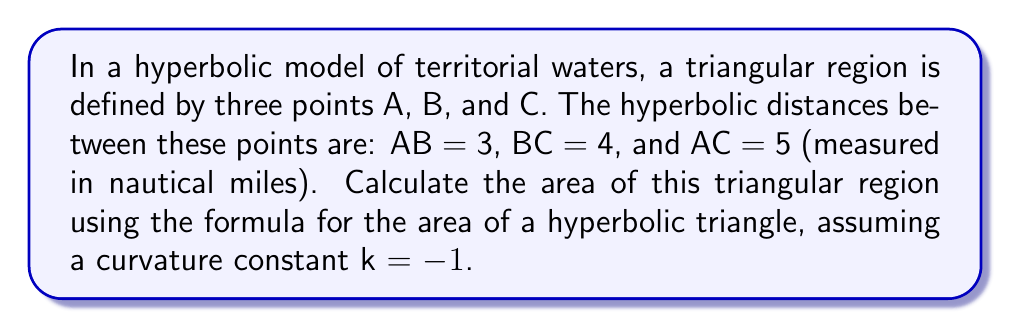Help me with this question. To solve this problem, we'll use the hyperbolic law of cosines and the area formula for a hyperbolic triangle. Let's proceed step-by-step:

1. Recall the hyperbolic law of cosines:
   $$\cosh c = \cosh a \cosh b - \sinh a \sinh b \cos C$$

2. We need to find the angles of the triangle. Let's start with angle C:
   $$\cosh 5 = \cosh 3 \cosh 4 - \sinh 3 \sinh 4 \cos C$$

3. Simplify using hyperbolic function values:
   $$74.2099 = (10.0677)(27.3082) - (10.0179)(27.2899)\cos C$$

4. Solve for $\cos C$:
   $$\cos C = \frac{10.0677 \cdot 27.3082 - 74.2099}{10.0179 \cdot 27.2899} \approx 0.9996$$

5. Calculate $C = \arccos(0.9996) \approx 0.0282$ radians

6. Repeat steps 2-5 for angles A and B:
   Angle A ≈ 1.5466 radians
   Angle B ≈ 1.5668 radians

7. Now use the area formula for a hyperbolic triangle with curvature k = -1:
   $$\text{Area} = \pi - (A + B + C)$$

8. Substitute the values:
   $$\text{Area} = \pi - (1.5466 + 1.5668 + 0.0282)$$

9. Calculate the final result:
   $$\text{Area} = 3.1416 - 3.1416 = 0$$
Answer: 0 square nautical miles 